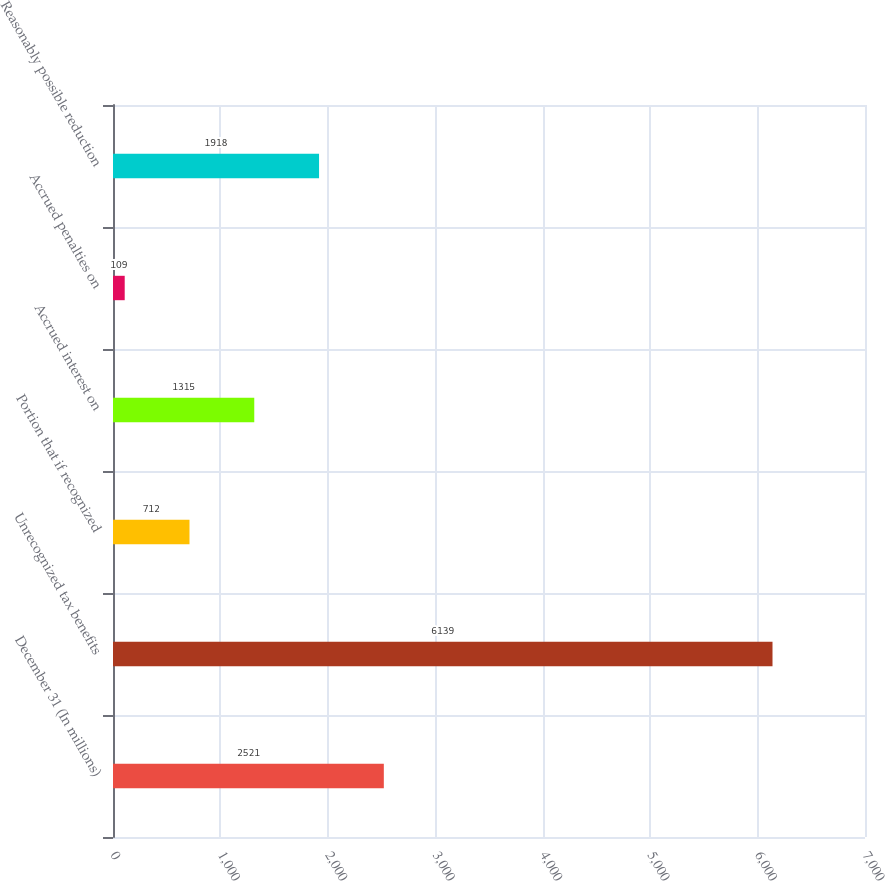Convert chart. <chart><loc_0><loc_0><loc_500><loc_500><bar_chart><fcel>December 31 (In millions)<fcel>Unrecognized tax benefits<fcel>Portion that if recognized<fcel>Accrued interest on<fcel>Accrued penalties on<fcel>Reasonably possible reduction<nl><fcel>2521<fcel>6139<fcel>712<fcel>1315<fcel>109<fcel>1918<nl></chart> 